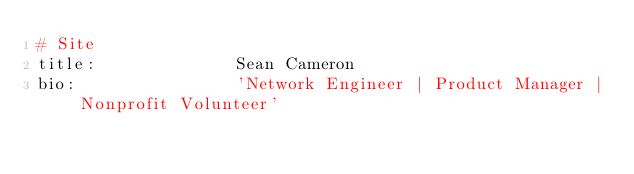<code> <loc_0><loc_0><loc_500><loc_500><_YAML_># Site
title:              Sean Cameron
bio:                'Network Engineer | Product Manager | Nonprofit Volunteer'</code> 